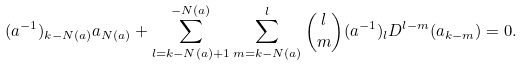<formula> <loc_0><loc_0><loc_500><loc_500>( a ^ { - 1 } ) _ { k - N ( a ) } a _ { N ( a ) } + \sum _ { l = k - N ( a ) + 1 } ^ { - N ( a ) } \sum _ { m = k - N ( a ) } ^ { l } \binom { l } { m } ( a ^ { - 1 } ) _ { l } D ^ { l - m } ( a _ { k - m } ) = 0 .</formula> 